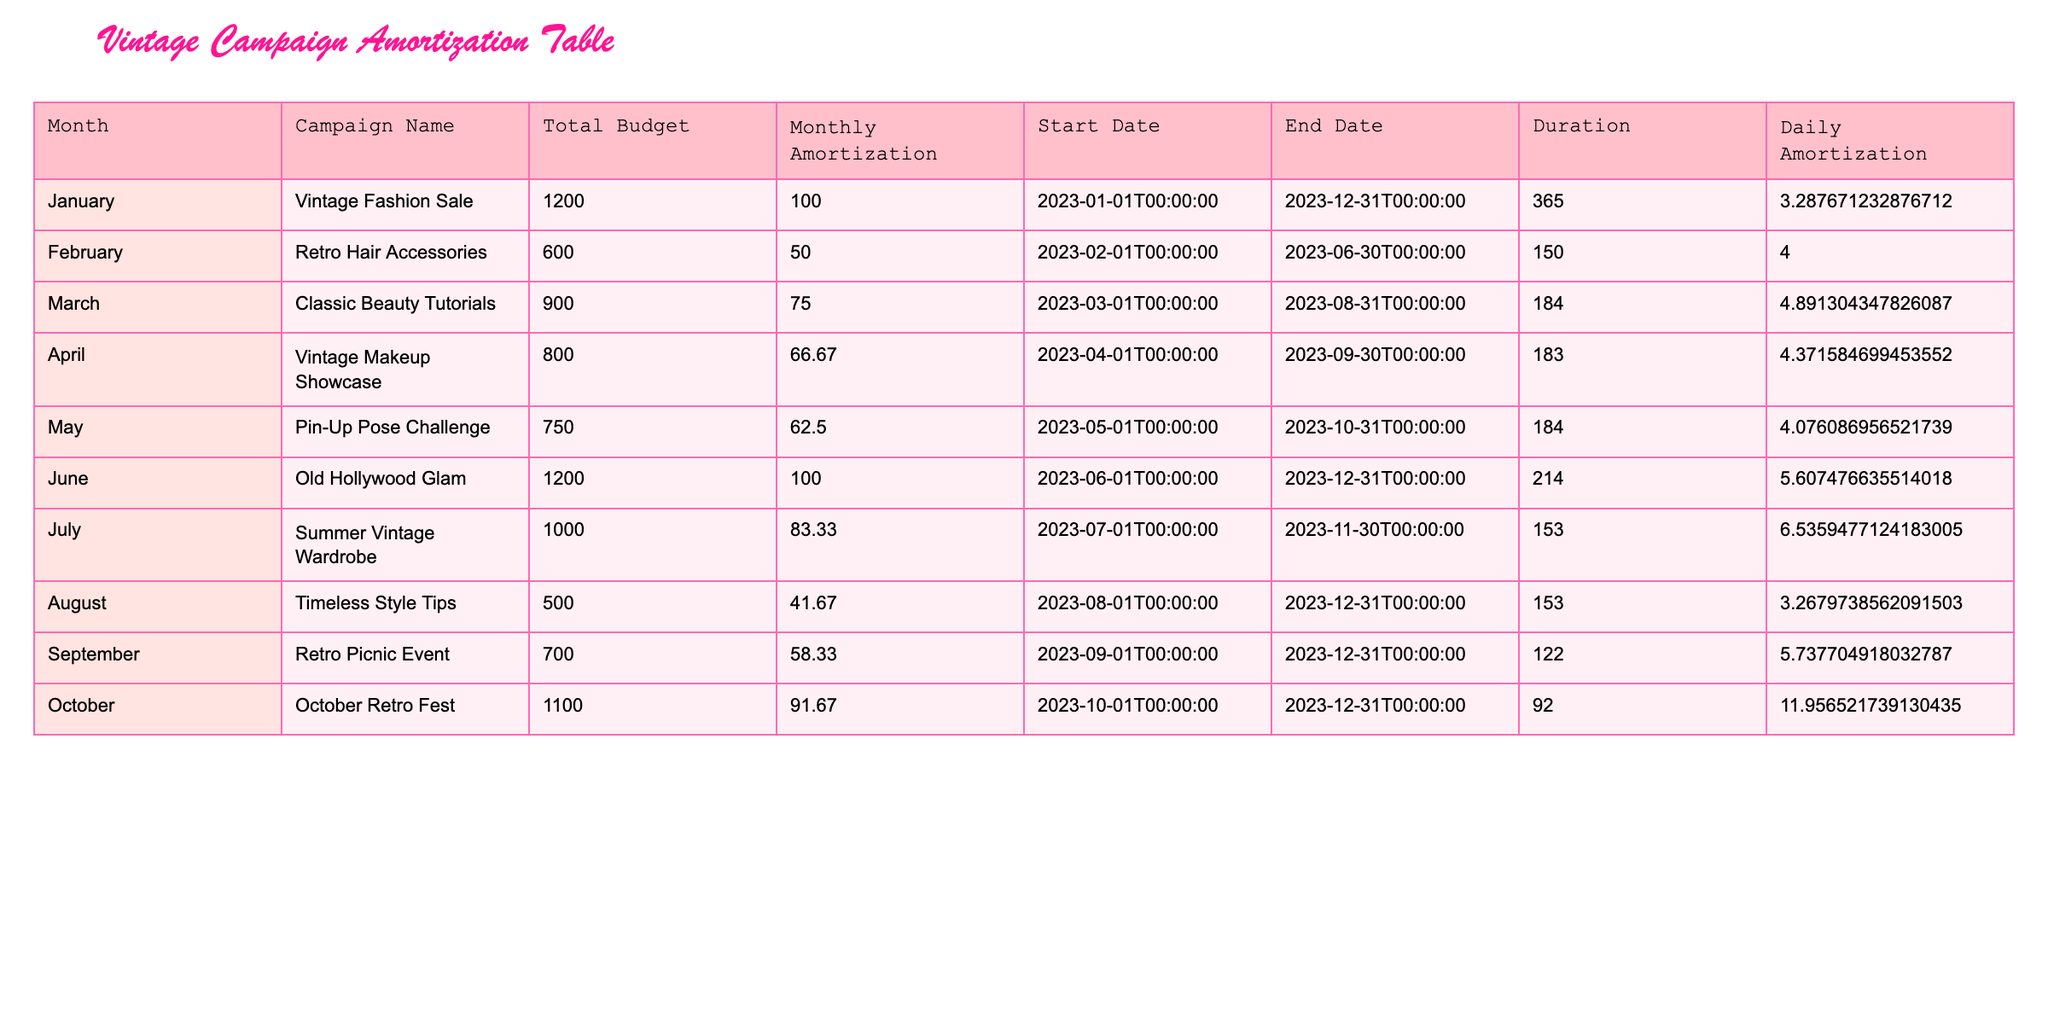What is the total budget for the "Vintage Fashion Sale" campaign? The table lists the "Vintage Fashion Sale" campaign under the "Campaign Name" column, and the corresponding "Total Budget" is found in the same row. The value is 1200.
Answer: 1200 How many campaigns have a monthly amortization of less than 70? By looking at the "Monthly Amortization" column, I can see that the values below 70 are 50, 66.67, and 62.50, corresponding to three campaigns: "Retro Hair Accessories," "Vintage Makeup Showcase," and "Pin-Up Pose Challenge." Therefore, the total count is three.
Answer: 3 What is the average monthly amortization across all campaigns? To calculate the average, I add all the monthly amortization values: 100 + 50 + 75 + 66.67 + 62.50 + 100 + 83.33 + 41.67 + 58.33 + 91.67 = 829.17. There are 10 campaigns, so I divide the total by 10 to get the average: 829.17 / 10 = 82.92.
Answer: 82.92 Is it true that all campaigns have budgets above 500? By inspecting the "Total Budget" column, the "Timeless Style Tips" campaign shows a budget of 500, while all others are higher. Since one campaign equals 500, the statement is true that no campaign is below that amount.
Answer: Yes What is the total budget for campaigns that run from March to October? The applicable campaigns are "Classic Beauty Tutorials," "Vintage Makeup Showcase," "Pin-Up Pose Challenge," "Old Hollywood Glam," "Summer Vintage Wardrobe," "Timeless Style Tips," "Retro Picnic Event," and "October Retro Fest." Their respective budgets are 900, 800, 750, 1200, 1000, 500, 700, and 1100. Adding these budgets gives 900 + 800 + 750 + 1200 + 1000 + 500 + 700 + 1100 = 5150. Therefore, the total budget for these campaigns is 5150.
Answer: 5150 